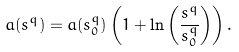<formula> <loc_0><loc_0><loc_500><loc_500>a ( s ^ { q } ) = a ( s ^ { q } _ { 0 } ) \left ( 1 + \ln \left ( \frac { s ^ { q } } { s ^ { q } _ { 0 } } \right ) \right ) .</formula> 